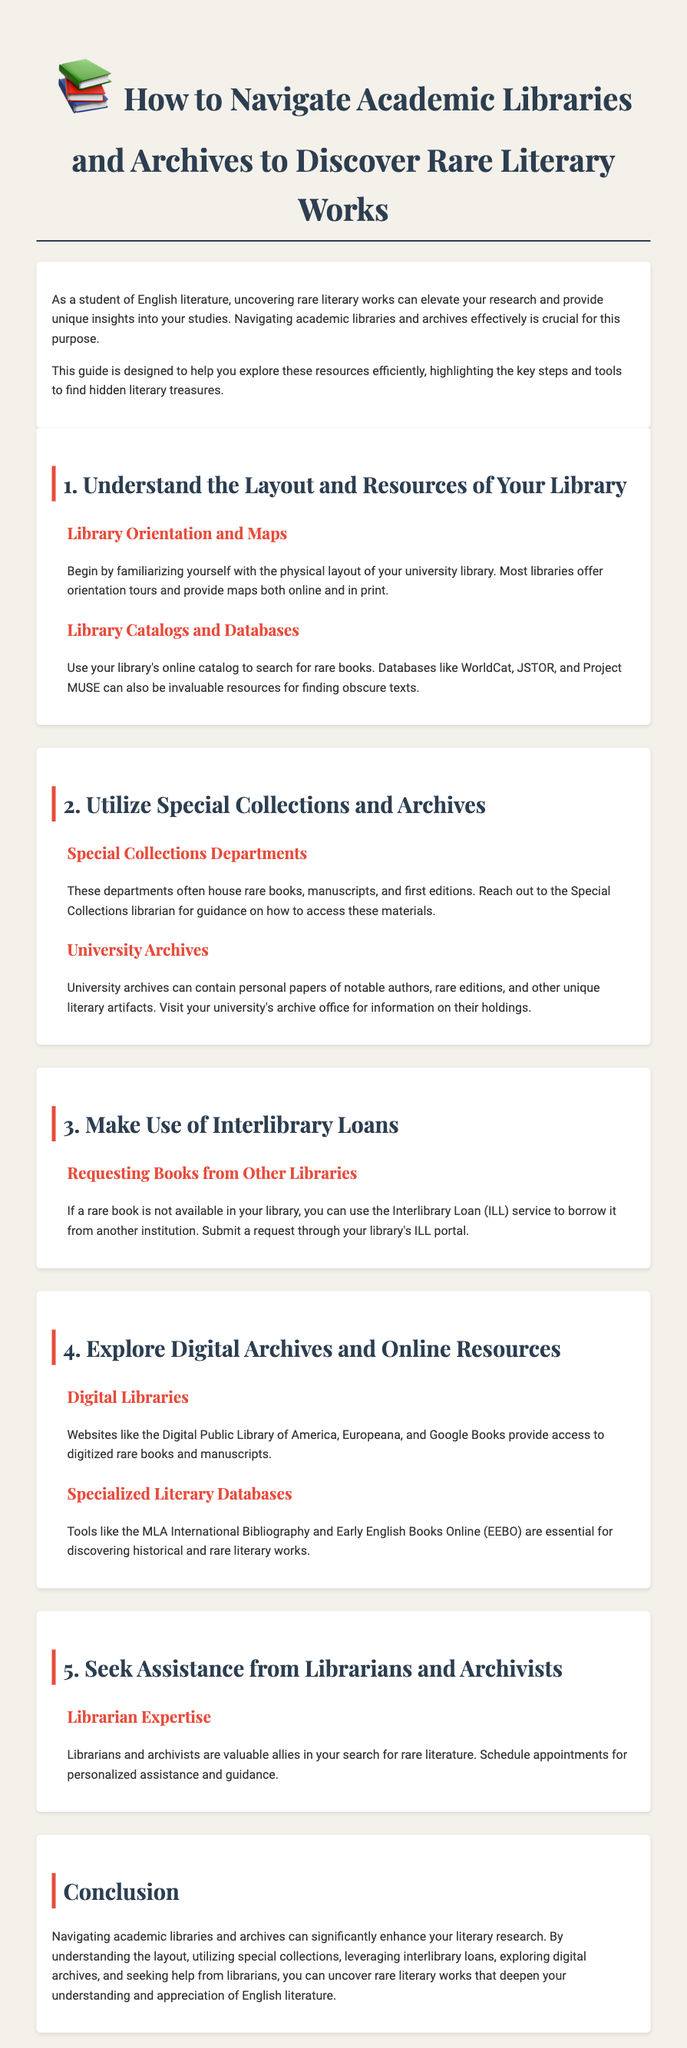What is the purpose of the guide? The purpose of the guide is to help explore academic libraries and archives efficiently and highlight key steps to find hidden literary treasures.
Answer: to help explore academic libraries and archives efficiently What are some databases mentioned for finding rare books? The document lists WorldCat, JSTOR, and Project MUSE as databases for finding obscure texts.
Answer: WorldCat, JSTOR, Project MUSE What should you do if a rare book is not available in your library? You can use the Interlibrary Loan (ILL) service to borrow it from another institution.
Answer: use Interlibrary Loan (ILL) What is a valuable resource for accessing digitized rare books? Websites like the Digital Public Library of America provide access to digitized rare books and manuscripts.
Answer: Digital Public Library of America Who can provide personalized assistance in locating rare literature? Librarians and archivists can offer personalized assistance in searching for rare literature.
Answer: Librarians and archivists What should you familiarize yourself with at the beginning? You should familiarize yourself with the physical layout of your university library.
Answer: physical layout of your university library How many sections are there in the guide? The guide consists of five main sections.
Answer: five What is the title of the document? The title of the document is "How to Navigate Academic Libraries and Archives to Discover Rare Literary Works."
Answer: How to Navigate Academic Libraries and Archives to Discover Rare Literary Works What does the conclusion emphasize? The conclusion emphasizes that navigating academic libraries can enhance literary research.
Answer: enhance literary research 